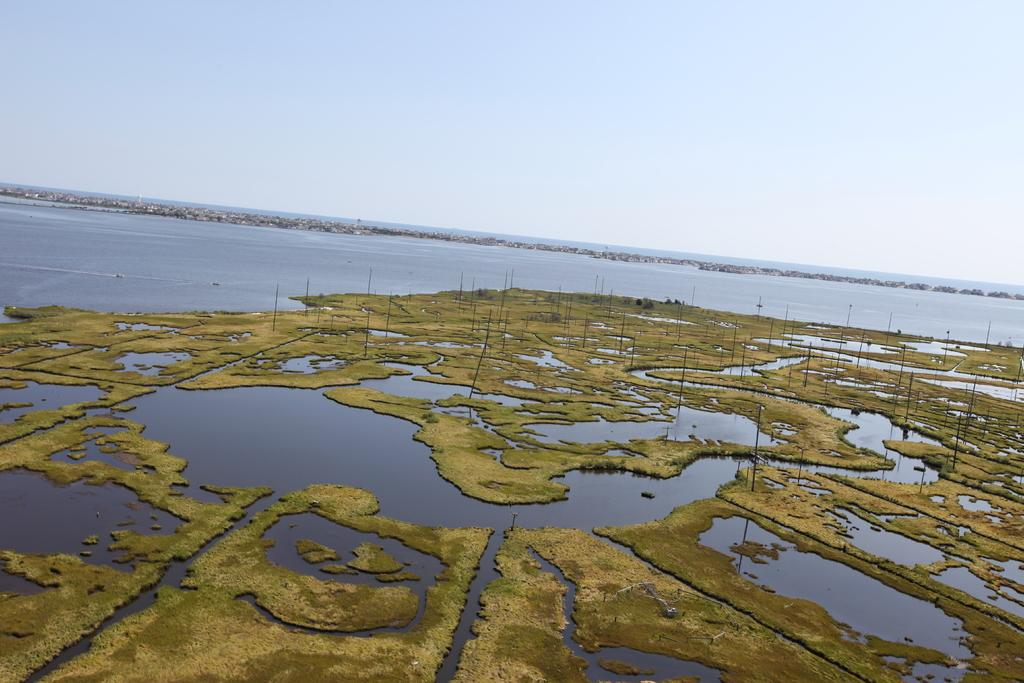What is present in the image? There is water and land visible in the image. Can you describe the water in the image? The image only shows water and land, without specific details about the water. What type of environment might the image depict? The image might depict a coastal or lake environment, given the presence of water and land. What type of pollution can be seen in the image? There is no pollution present in the image; it only shows water and land. Is there a church visible in the image? There is no church present in the image; it only shows water and land. 